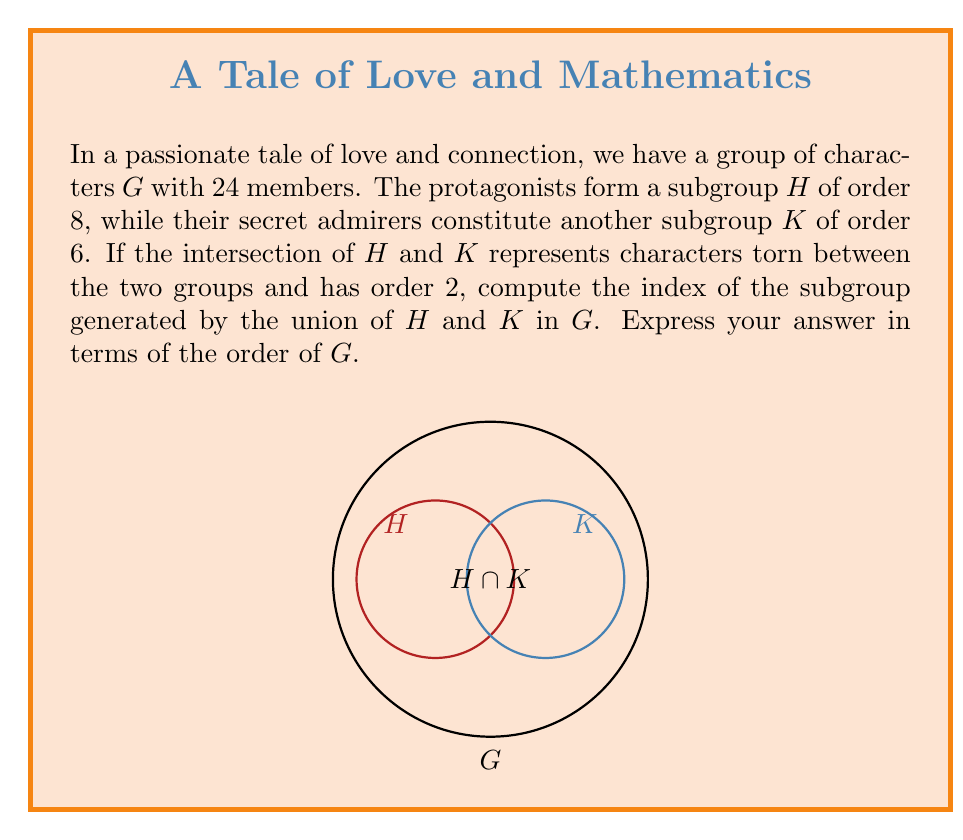Provide a solution to this math problem. Let's approach this step-by-step:

1) First, we need to find the order of the subgroup generated by the union of $H$ and $K$, which we'll call $\langle H \cup K \rangle$.

2) We can use the formula: $|\langle H \cup K \rangle| = \frac{|H||K|}{|H \cap K|}$

3) We're given:
   $|H| = 8$
   $|K| = 6$
   $|H \cap K| = 2$

4) Substituting these values:

   $$|\langle H \cup K \rangle| = \frac{8 \cdot 6}{2} = 24$$

5) Now, we need to find the index of $\langle H \cup K \rangle$ in $G$.

6) The index of a subgroup is defined as the number of cosets of the subgroup in the group. It's calculated as:

   $$[G : \langle H \cup K \rangle] = \frac{|G|}{|\langle H \cup K \rangle|}$$

7) We're given that $|G| = 24$, and we just calculated that $|\langle H \cup K \rangle| = 24$

8) Therefore:

   $$[G : \langle H \cup K \rangle] = \frac{24}{24} = 1$$

9) To express this in terms of the order of $G$, we can write:

   $$[G : \langle H \cup K \rangle] = \frac{|G|}{|G|} = 1$$
Answer: $\frac{|G|}{|G|}$ 